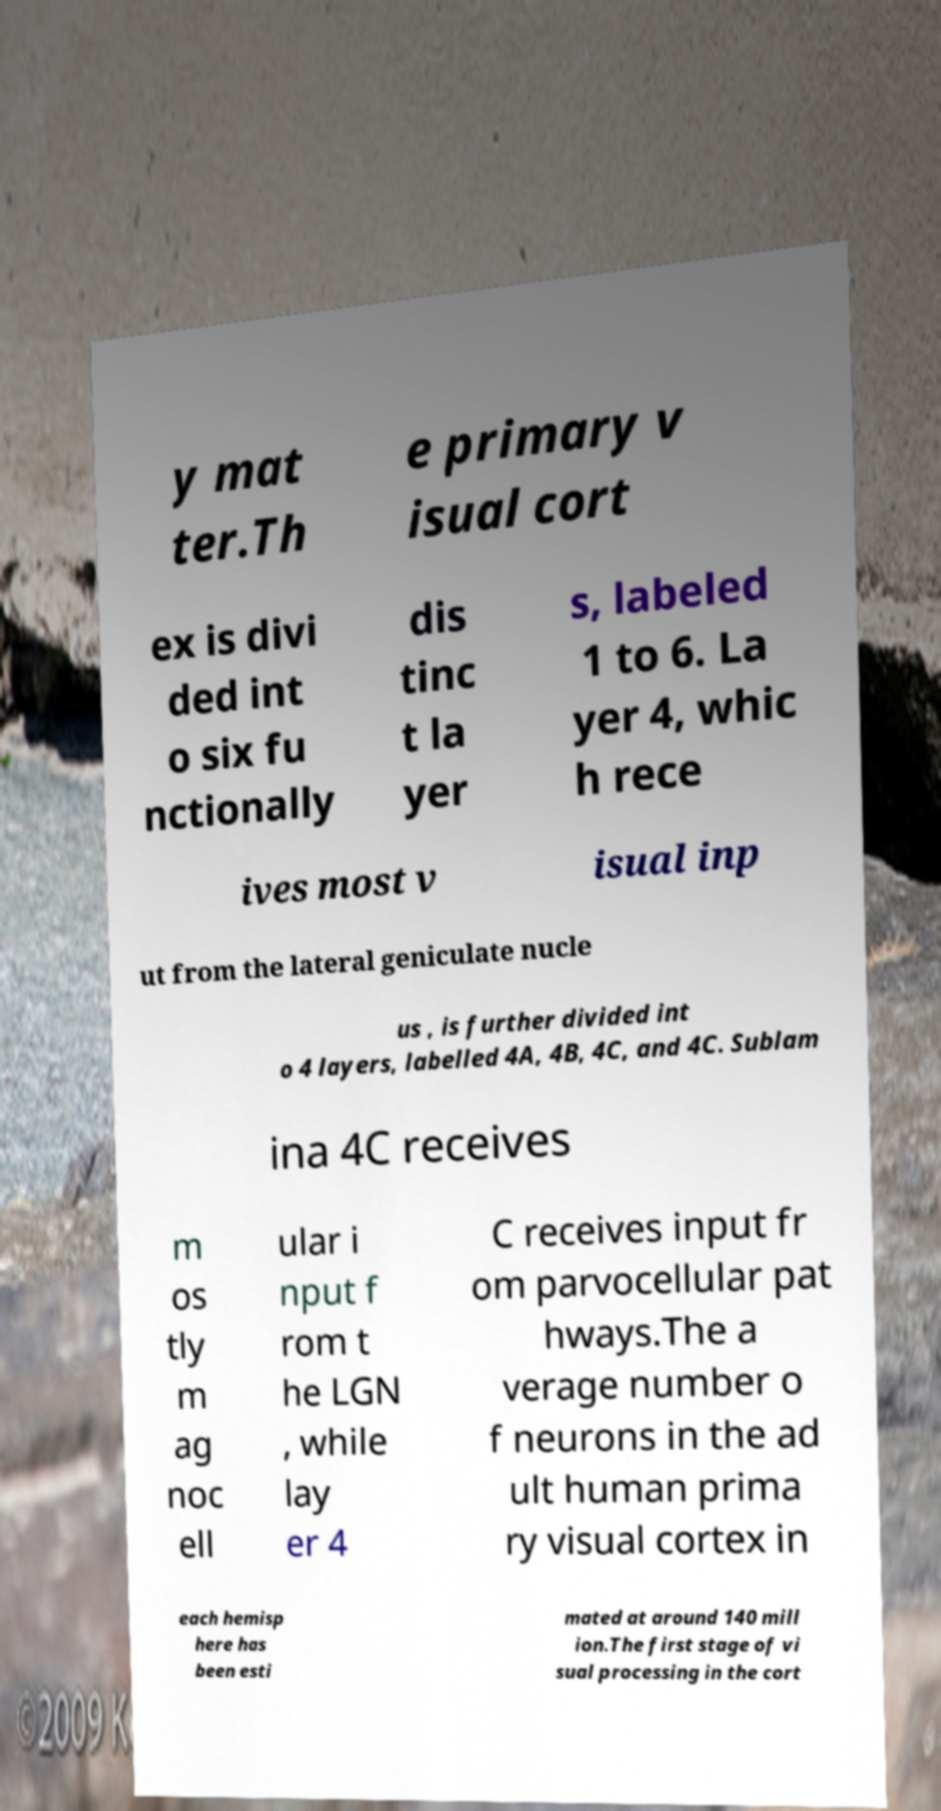I need the written content from this picture converted into text. Can you do that? y mat ter.Th e primary v isual cort ex is divi ded int o six fu nctionally dis tinc t la yer s, labeled 1 to 6. La yer 4, whic h rece ives most v isual inp ut from the lateral geniculate nucle us , is further divided int o 4 layers, labelled 4A, 4B, 4C, and 4C. Sublam ina 4C receives m os tly m ag noc ell ular i nput f rom t he LGN , while lay er 4 C receives input fr om parvocellular pat hways.The a verage number o f neurons in the ad ult human prima ry visual cortex in each hemisp here has been esti mated at around 140 mill ion.The first stage of vi sual processing in the cort 